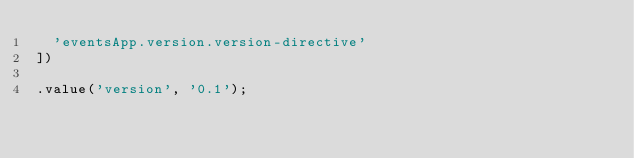Convert code to text. <code><loc_0><loc_0><loc_500><loc_500><_JavaScript_>  'eventsApp.version.version-directive'
])

.value('version', '0.1');
</code> 